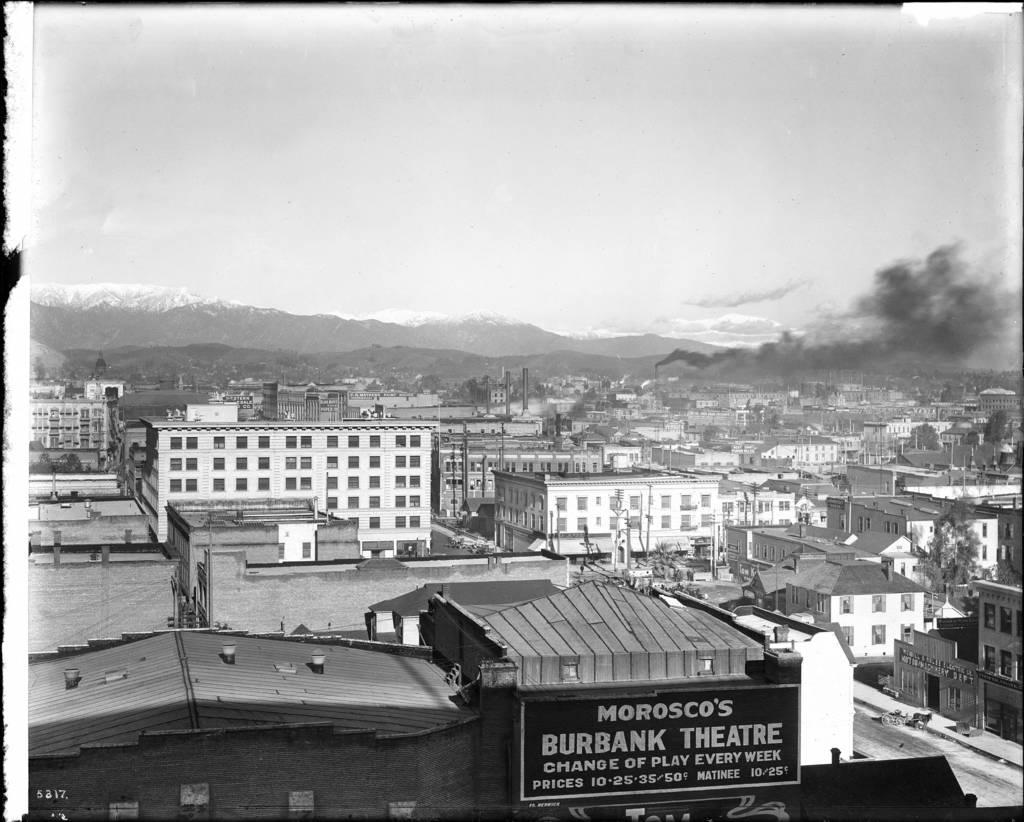<image>
Present a compact description of the photo's key features. Morosco's burbank theatre sign is hanging on a building 